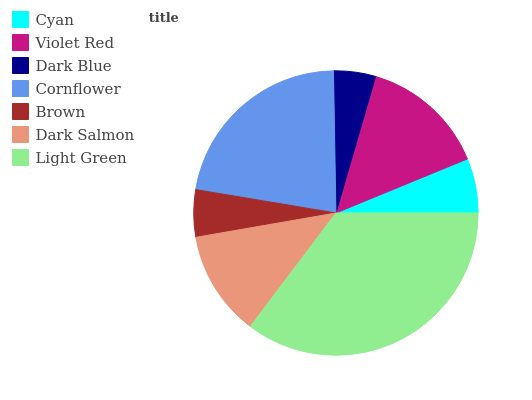Is Dark Blue the minimum?
Answer yes or no. Yes. Is Light Green the maximum?
Answer yes or no. Yes. Is Violet Red the minimum?
Answer yes or no. No. Is Violet Red the maximum?
Answer yes or no. No. Is Violet Red greater than Cyan?
Answer yes or no. Yes. Is Cyan less than Violet Red?
Answer yes or no. Yes. Is Cyan greater than Violet Red?
Answer yes or no. No. Is Violet Red less than Cyan?
Answer yes or no. No. Is Dark Salmon the high median?
Answer yes or no. Yes. Is Dark Salmon the low median?
Answer yes or no. Yes. Is Light Green the high median?
Answer yes or no. No. Is Violet Red the low median?
Answer yes or no. No. 